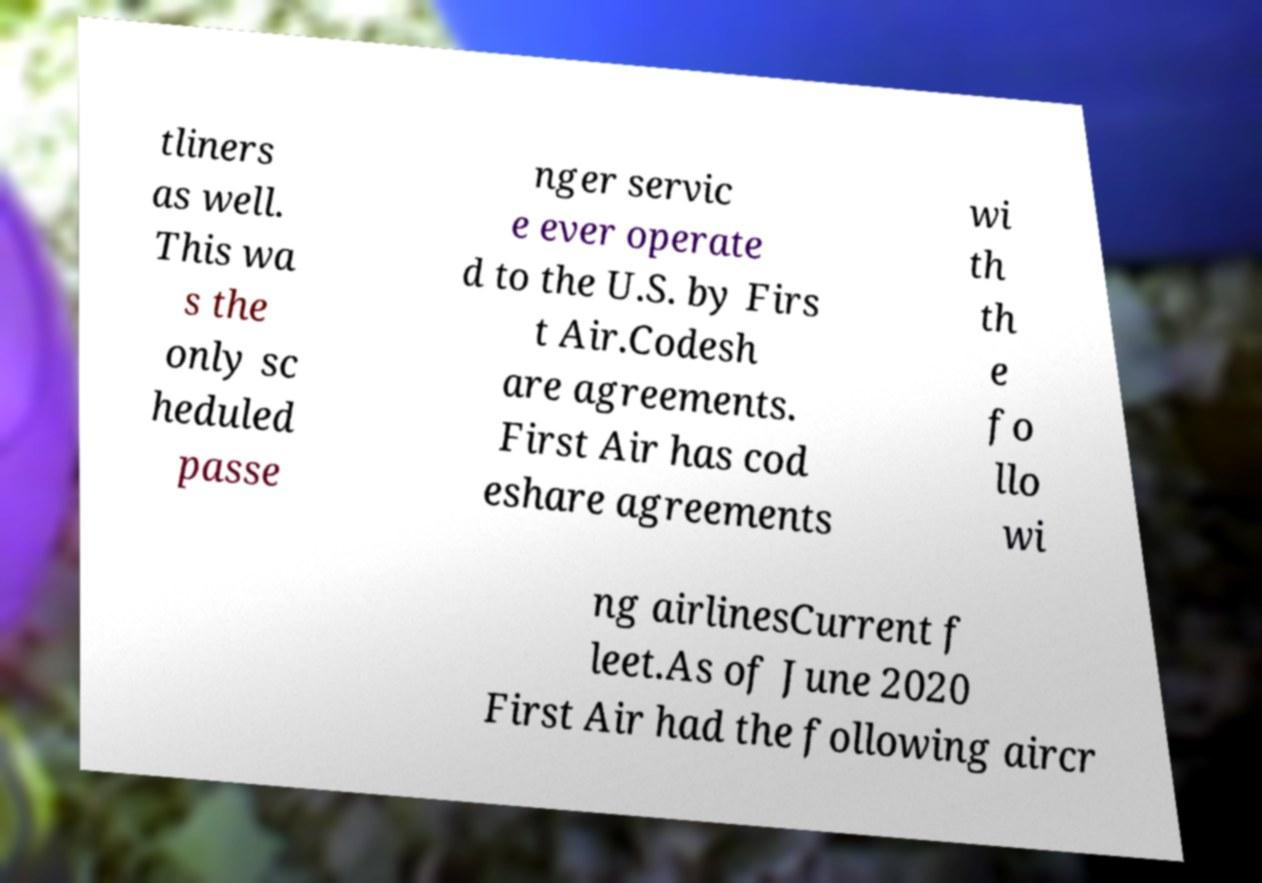Please read and relay the text visible in this image. What does it say? tliners as well. This wa s the only sc heduled passe nger servic e ever operate d to the U.S. by Firs t Air.Codesh are agreements. First Air has cod eshare agreements wi th th e fo llo wi ng airlinesCurrent f leet.As of June 2020 First Air had the following aircr 